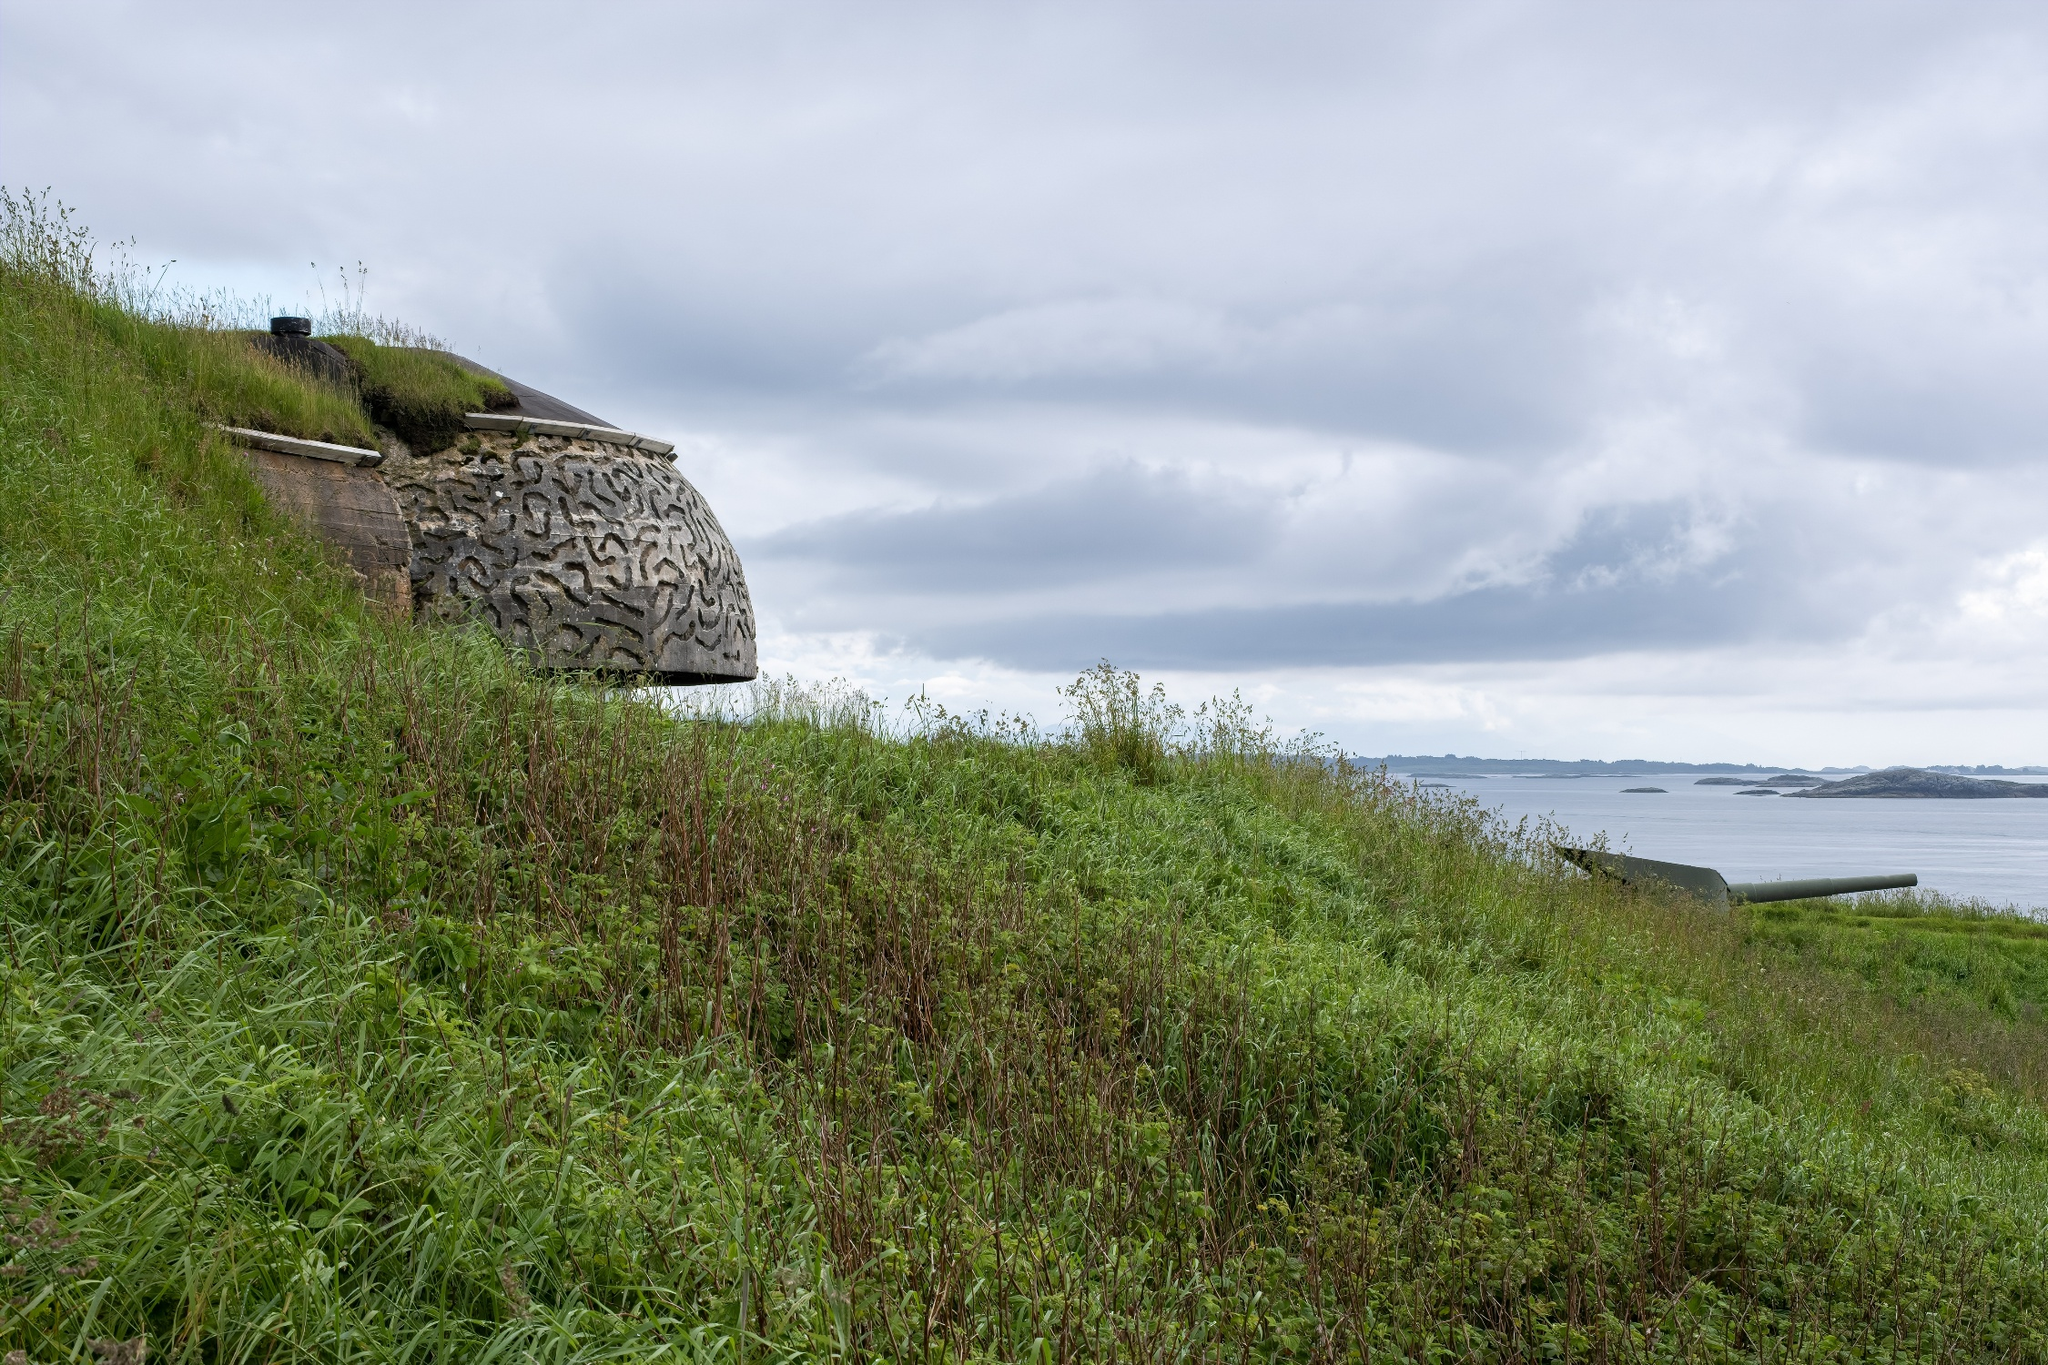What components of nature and human construction stand out in this image? The image showcases a compelling blend of nature and human construction. The most prominent human-made feature is the stone bunker with its complex pattern of interwoven lines, noticeable on the left side. Nature's elements include the lush hillside covered in green grass and scattered shrubs, which gently slopes down towards the ocean in the background. The expansive sky filled with varying cloud formations further enhances the natural beauty of the scene. Together, these components highlight a harmonious coexistence between human structures and the natural environment. 